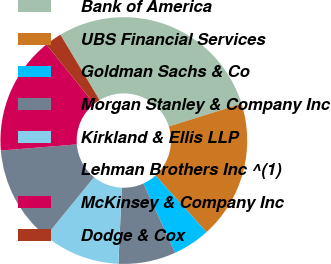Convert chart to OTSL. <chart><loc_0><loc_0><loc_500><loc_500><pie_chart><fcel>Bank of America<fcel>UBS Financial Services<fcel>Goldman Sachs & Co<fcel>Morgan Stanley & Company Inc<fcel>Kirkland & Ellis LLP<fcel>Lehman Brothers Inc ^(1)<fcel>McKinsey & Company Inc<fcel>Dodge & Cox<nl><fcel>28.76%<fcel>18.14%<fcel>4.87%<fcel>7.52%<fcel>10.18%<fcel>12.83%<fcel>15.49%<fcel>2.21%<nl></chart> 